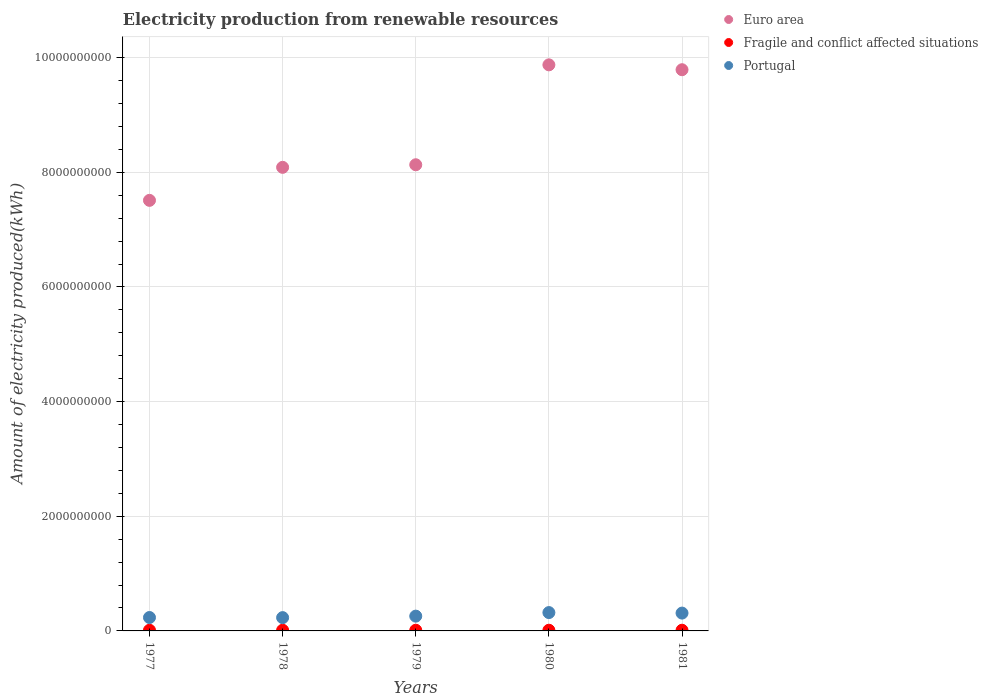What is the amount of electricity produced in Euro area in 1977?
Provide a succinct answer. 7.51e+09. Across all years, what is the minimum amount of electricity produced in Portugal?
Keep it short and to the point. 2.32e+08. In which year was the amount of electricity produced in Euro area maximum?
Ensure brevity in your answer.  1980. What is the total amount of electricity produced in Fragile and conflict affected situations in the graph?
Ensure brevity in your answer.  6.00e+07. What is the difference between the amount of electricity produced in Fragile and conflict affected situations in 1979 and the amount of electricity produced in Euro area in 1978?
Your answer should be very brief. -8.08e+09. What is the average amount of electricity produced in Euro area per year?
Keep it short and to the point. 8.68e+09. In the year 1981, what is the difference between the amount of electricity produced in Portugal and amount of electricity produced in Euro area?
Provide a short and direct response. -9.48e+09. In how many years, is the amount of electricity produced in Fragile and conflict affected situations greater than 8800000000 kWh?
Keep it short and to the point. 0. Is the amount of electricity produced in Euro area in 1977 less than that in 1981?
Your answer should be compact. Yes. Is the difference between the amount of electricity produced in Portugal in 1978 and 1979 greater than the difference between the amount of electricity produced in Euro area in 1978 and 1979?
Your answer should be very brief. Yes. What is the difference between the highest and the second highest amount of electricity produced in Portugal?
Make the answer very short. 9.00e+06. What is the difference between the highest and the lowest amount of electricity produced in Portugal?
Offer a terse response. 8.80e+07. Is the amount of electricity produced in Fragile and conflict affected situations strictly greater than the amount of electricity produced in Portugal over the years?
Offer a terse response. No. Is the amount of electricity produced in Fragile and conflict affected situations strictly less than the amount of electricity produced in Portugal over the years?
Provide a short and direct response. Yes. What is the difference between two consecutive major ticks on the Y-axis?
Give a very brief answer. 2.00e+09. Are the values on the major ticks of Y-axis written in scientific E-notation?
Your answer should be very brief. No. Does the graph contain any zero values?
Keep it short and to the point. No. Where does the legend appear in the graph?
Offer a very short reply. Top right. How many legend labels are there?
Give a very brief answer. 3. What is the title of the graph?
Make the answer very short. Electricity production from renewable resources. What is the label or title of the Y-axis?
Ensure brevity in your answer.  Amount of electricity produced(kWh). What is the Amount of electricity produced(kWh) in Euro area in 1977?
Offer a very short reply. 7.51e+09. What is the Amount of electricity produced(kWh) in Portugal in 1977?
Make the answer very short. 2.34e+08. What is the Amount of electricity produced(kWh) in Euro area in 1978?
Make the answer very short. 8.09e+09. What is the Amount of electricity produced(kWh) of Portugal in 1978?
Ensure brevity in your answer.  2.32e+08. What is the Amount of electricity produced(kWh) of Euro area in 1979?
Offer a terse response. 8.13e+09. What is the Amount of electricity produced(kWh) in Fragile and conflict affected situations in 1979?
Provide a short and direct response. 1.20e+07. What is the Amount of electricity produced(kWh) of Portugal in 1979?
Keep it short and to the point. 2.58e+08. What is the Amount of electricity produced(kWh) in Euro area in 1980?
Keep it short and to the point. 9.88e+09. What is the Amount of electricity produced(kWh) of Fragile and conflict affected situations in 1980?
Give a very brief answer. 1.20e+07. What is the Amount of electricity produced(kWh) of Portugal in 1980?
Give a very brief answer. 3.20e+08. What is the Amount of electricity produced(kWh) in Euro area in 1981?
Your answer should be compact. 9.79e+09. What is the Amount of electricity produced(kWh) of Portugal in 1981?
Offer a terse response. 3.11e+08. Across all years, what is the maximum Amount of electricity produced(kWh) of Euro area?
Ensure brevity in your answer.  9.88e+09. Across all years, what is the maximum Amount of electricity produced(kWh) of Fragile and conflict affected situations?
Make the answer very short. 1.20e+07. Across all years, what is the maximum Amount of electricity produced(kWh) of Portugal?
Provide a succinct answer. 3.20e+08. Across all years, what is the minimum Amount of electricity produced(kWh) of Euro area?
Keep it short and to the point. 7.51e+09. Across all years, what is the minimum Amount of electricity produced(kWh) of Fragile and conflict affected situations?
Make the answer very short. 1.20e+07. Across all years, what is the minimum Amount of electricity produced(kWh) of Portugal?
Provide a short and direct response. 2.32e+08. What is the total Amount of electricity produced(kWh) in Euro area in the graph?
Offer a terse response. 4.34e+1. What is the total Amount of electricity produced(kWh) in Fragile and conflict affected situations in the graph?
Make the answer very short. 6.00e+07. What is the total Amount of electricity produced(kWh) of Portugal in the graph?
Your answer should be very brief. 1.36e+09. What is the difference between the Amount of electricity produced(kWh) in Euro area in 1977 and that in 1978?
Give a very brief answer. -5.76e+08. What is the difference between the Amount of electricity produced(kWh) in Euro area in 1977 and that in 1979?
Offer a terse response. -6.21e+08. What is the difference between the Amount of electricity produced(kWh) of Fragile and conflict affected situations in 1977 and that in 1979?
Make the answer very short. 0. What is the difference between the Amount of electricity produced(kWh) of Portugal in 1977 and that in 1979?
Your answer should be very brief. -2.40e+07. What is the difference between the Amount of electricity produced(kWh) in Euro area in 1977 and that in 1980?
Give a very brief answer. -2.36e+09. What is the difference between the Amount of electricity produced(kWh) in Fragile and conflict affected situations in 1977 and that in 1980?
Provide a succinct answer. 0. What is the difference between the Amount of electricity produced(kWh) in Portugal in 1977 and that in 1980?
Keep it short and to the point. -8.60e+07. What is the difference between the Amount of electricity produced(kWh) in Euro area in 1977 and that in 1981?
Offer a very short reply. -2.28e+09. What is the difference between the Amount of electricity produced(kWh) of Fragile and conflict affected situations in 1977 and that in 1981?
Give a very brief answer. 0. What is the difference between the Amount of electricity produced(kWh) in Portugal in 1977 and that in 1981?
Give a very brief answer. -7.70e+07. What is the difference between the Amount of electricity produced(kWh) in Euro area in 1978 and that in 1979?
Offer a very short reply. -4.50e+07. What is the difference between the Amount of electricity produced(kWh) in Fragile and conflict affected situations in 1978 and that in 1979?
Provide a short and direct response. 0. What is the difference between the Amount of electricity produced(kWh) in Portugal in 1978 and that in 1979?
Your answer should be very brief. -2.60e+07. What is the difference between the Amount of electricity produced(kWh) in Euro area in 1978 and that in 1980?
Make the answer very short. -1.79e+09. What is the difference between the Amount of electricity produced(kWh) of Fragile and conflict affected situations in 1978 and that in 1980?
Your answer should be compact. 0. What is the difference between the Amount of electricity produced(kWh) in Portugal in 1978 and that in 1980?
Offer a very short reply. -8.80e+07. What is the difference between the Amount of electricity produced(kWh) in Euro area in 1978 and that in 1981?
Give a very brief answer. -1.70e+09. What is the difference between the Amount of electricity produced(kWh) of Portugal in 1978 and that in 1981?
Your answer should be compact. -7.90e+07. What is the difference between the Amount of electricity produced(kWh) of Euro area in 1979 and that in 1980?
Make the answer very short. -1.74e+09. What is the difference between the Amount of electricity produced(kWh) of Fragile and conflict affected situations in 1979 and that in 1980?
Give a very brief answer. 0. What is the difference between the Amount of electricity produced(kWh) in Portugal in 1979 and that in 1980?
Your answer should be very brief. -6.20e+07. What is the difference between the Amount of electricity produced(kWh) in Euro area in 1979 and that in 1981?
Offer a very short reply. -1.66e+09. What is the difference between the Amount of electricity produced(kWh) of Fragile and conflict affected situations in 1979 and that in 1981?
Your response must be concise. 0. What is the difference between the Amount of electricity produced(kWh) of Portugal in 1979 and that in 1981?
Give a very brief answer. -5.30e+07. What is the difference between the Amount of electricity produced(kWh) of Euro area in 1980 and that in 1981?
Provide a short and direct response. 8.50e+07. What is the difference between the Amount of electricity produced(kWh) of Portugal in 1980 and that in 1981?
Your answer should be very brief. 9.00e+06. What is the difference between the Amount of electricity produced(kWh) in Euro area in 1977 and the Amount of electricity produced(kWh) in Fragile and conflict affected situations in 1978?
Offer a terse response. 7.50e+09. What is the difference between the Amount of electricity produced(kWh) in Euro area in 1977 and the Amount of electricity produced(kWh) in Portugal in 1978?
Your answer should be very brief. 7.28e+09. What is the difference between the Amount of electricity produced(kWh) of Fragile and conflict affected situations in 1977 and the Amount of electricity produced(kWh) of Portugal in 1978?
Give a very brief answer. -2.20e+08. What is the difference between the Amount of electricity produced(kWh) in Euro area in 1977 and the Amount of electricity produced(kWh) in Fragile and conflict affected situations in 1979?
Offer a terse response. 7.50e+09. What is the difference between the Amount of electricity produced(kWh) in Euro area in 1977 and the Amount of electricity produced(kWh) in Portugal in 1979?
Ensure brevity in your answer.  7.25e+09. What is the difference between the Amount of electricity produced(kWh) in Fragile and conflict affected situations in 1977 and the Amount of electricity produced(kWh) in Portugal in 1979?
Keep it short and to the point. -2.46e+08. What is the difference between the Amount of electricity produced(kWh) in Euro area in 1977 and the Amount of electricity produced(kWh) in Fragile and conflict affected situations in 1980?
Provide a short and direct response. 7.50e+09. What is the difference between the Amount of electricity produced(kWh) of Euro area in 1977 and the Amount of electricity produced(kWh) of Portugal in 1980?
Your answer should be very brief. 7.19e+09. What is the difference between the Amount of electricity produced(kWh) of Fragile and conflict affected situations in 1977 and the Amount of electricity produced(kWh) of Portugal in 1980?
Offer a terse response. -3.08e+08. What is the difference between the Amount of electricity produced(kWh) in Euro area in 1977 and the Amount of electricity produced(kWh) in Fragile and conflict affected situations in 1981?
Provide a succinct answer. 7.50e+09. What is the difference between the Amount of electricity produced(kWh) of Euro area in 1977 and the Amount of electricity produced(kWh) of Portugal in 1981?
Offer a terse response. 7.20e+09. What is the difference between the Amount of electricity produced(kWh) in Fragile and conflict affected situations in 1977 and the Amount of electricity produced(kWh) in Portugal in 1981?
Your response must be concise. -2.99e+08. What is the difference between the Amount of electricity produced(kWh) in Euro area in 1978 and the Amount of electricity produced(kWh) in Fragile and conflict affected situations in 1979?
Offer a terse response. 8.08e+09. What is the difference between the Amount of electricity produced(kWh) of Euro area in 1978 and the Amount of electricity produced(kWh) of Portugal in 1979?
Make the answer very short. 7.83e+09. What is the difference between the Amount of electricity produced(kWh) in Fragile and conflict affected situations in 1978 and the Amount of electricity produced(kWh) in Portugal in 1979?
Provide a succinct answer. -2.46e+08. What is the difference between the Amount of electricity produced(kWh) in Euro area in 1978 and the Amount of electricity produced(kWh) in Fragile and conflict affected situations in 1980?
Offer a very short reply. 8.08e+09. What is the difference between the Amount of electricity produced(kWh) in Euro area in 1978 and the Amount of electricity produced(kWh) in Portugal in 1980?
Offer a very short reply. 7.77e+09. What is the difference between the Amount of electricity produced(kWh) of Fragile and conflict affected situations in 1978 and the Amount of electricity produced(kWh) of Portugal in 1980?
Make the answer very short. -3.08e+08. What is the difference between the Amount of electricity produced(kWh) of Euro area in 1978 and the Amount of electricity produced(kWh) of Fragile and conflict affected situations in 1981?
Keep it short and to the point. 8.08e+09. What is the difference between the Amount of electricity produced(kWh) in Euro area in 1978 and the Amount of electricity produced(kWh) in Portugal in 1981?
Offer a terse response. 7.78e+09. What is the difference between the Amount of electricity produced(kWh) in Fragile and conflict affected situations in 1978 and the Amount of electricity produced(kWh) in Portugal in 1981?
Provide a short and direct response. -2.99e+08. What is the difference between the Amount of electricity produced(kWh) of Euro area in 1979 and the Amount of electricity produced(kWh) of Fragile and conflict affected situations in 1980?
Your answer should be very brief. 8.12e+09. What is the difference between the Amount of electricity produced(kWh) of Euro area in 1979 and the Amount of electricity produced(kWh) of Portugal in 1980?
Make the answer very short. 7.81e+09. What is the difference between the Amount of electricity produced(kWh) in Fragile and conflict affected situations in 1979 and the Amount of electricity produced(kWh) in Portugal in 1980?
Provide a short and direct response. -3.08e+08. What is the difference between the Amount of electricity produced(kWh) of Euro area in 1979 and the Amount of electricity produced(kWh) of Fragile and conflict affected situations in 1981?
Give a very brief answer. 8.12e+09. What is the difference between the Amount of electricity produced(kWh) of Euro area in 1979 and the Amount of electricity produced(kWh) of Portugal in 1981?
Provide a succinct answer. 7.82e+09. What is the difference between the Amount of electricity produced(kWh) of Fragile and conflict affected situations in 1979 and the Amount of electricity produced(kWh) of Portugal in 1981?
Your response must be concise. -2.99e+08. What is the difference between the Amount of electricity produced(kWh) of Euro area in 1980 and the Amount of electricity produced(kWh) of Fragile and conflict affected situations in 1981?
Your answer should be very brief. 9.86e+09. What is the difference between the Amount of electricity produced(kWh) of Euro area in 1980 and the Amount of electricity produced(kWh) of Portugal in 1981?
Ensure brevity in your answer.  9.56e+09. What is the difference between the Amount of electricity produced(kWh) of Fragile and conflict affected situations in 1980 and the Amount of electricity produced(kWh) of Portugal in 1981?
Your response must be concise. -2.99e+08. What is the average Amount of electricity produced(kWh) in Euro area per year?
Give a very brief answer. 8.68e+09. What is the average Amount of electricity produced(kWh) of Portugal per year?
Your response must be concise. 2.71e+08. In the year 1977, what is the difference between the Amount of electricity produced(kWh) of Euro area and Amount of electricity produced(kWh) of Fragile and conflict affected situations?
Keep it short and to the point. 7.50e+09. In the year 1977, what is the difference between the Amount of electricity produced(kWh) in Euro area and Amount of electricity produced(kWh) in Portugal?
Give a very brief answer. 7.28e+09. In the year 1977, what is the difference between the Amount of electricity produced(kWh) of Fragile and conflict affected situations and Amount of electricity produced(kWh) of Portugal?
Your answer should be compact. -2.22e+08. In the year 1978, what is the difference between the Amount of electricity produced(kWh) in Euro area and Amount of electricity produced(kWh) in Fragile and conflict affected situations?
Ensure brevity in your answer.  8.08e+09. In the year 1978, what is the difference between the Amount of electricity produced(kWh) of Euro area and Amount of electricity produced(kWh) of Portugal?
Provide a short and direct response. 7.86e+09. In the year 1978, what is the difference between the Amount of electricity produced(kWh) of Fragile and conflict affected situations and Amount of electricity produced(kWh) of Portugal?
Your answer should be very brief. -2.20e+08. In the year 1979, what is the difference between the Amount of electricity produced(kWh) of Euro area and Amount of electricity produced(kWh) of Fragile and conflict affected situations?
Offer a terse response. 8.12e+09. In the year 1979, what is the difference between the Amount of electricity produced(kWh) in Euro area and Amount of electricity produced(kWh) in Portugal?
Give a very brief answer. 7.87e+09. In the year 1979, what is the difference between the Amount of electricity produced(kWh) in Fragile and conflict affected situations and Amount of electricity produced(kWh) in Portugal?
Give a very brief answer. -2.46e+08. In the year 1980, what is the difference between the Amount of electricity produced(kWh) of Euro area and Amount of electricity produced(kWh) of Fragile and conflict affected situations?
Your answer should be very brief. 9.86e+09. In the year 1980, what is the difference between the Amount of electricity produced(kWh) of Euro area and Amount of electricity produced(kWh) of Portugal?
Provide a short and direct response. 9.56e+09. In the year 1980, what is the difference between the Amount of electricity produced(kWh) of Fragile and conflict affected situations and Amount of electricity produced(kWh) of Portugal?
Offer a terse response. -3.08e+08. In the year 1981, what is the difference between the Amount of electricity produced(kWh) in Euro area and Amount of electricity produced(kWh) in Fragile and conflict affected situations?
Your answer should be compact. 9.78e+09. In the year 1981, what is the difference between the Amount of electricity produced(kWh) in Euro area and Amount of electricity produced(kWh) in Portugal?
Make the answer very short. 9.48e+09. In the year 1981, what is the difference between the Amount of electricity produced(kWh) in Fragile and conflict affected situations and Amount of electricity produced(kWh) in Portugal?
Provide a succinct answer. -2.99e+08. What is the ratio of the Amount of electricity produced(kWh) of Euro area in 1977 to that in 1978?
Offer a terse response. 0.93. What is the ratio of the Amount of electricity produced(kWh) of Portugal in 1977 to that in 1978?
Your response must be concise. 1.01. What is the ratio of the Amount of electricity produced(kWh) of Euro area in 1977 to that in 1979?
Provide a short and direct response. 0.92. What is the ratio of the Amount of electricity produced(kWh) in Fragile and conflict affected situations in 1977 to that in 1979?
Offer a terse response. 1. What is the ratio of the Amount of electricity produced(kWh) in Portugal in 1977 to that in 1979?
Offer a very short reply. 0.91. What is the ratio of the Amount of electricity produced(kWh) in Euro area in 1977 to that in 1980?
Your response must be concise. 0.76. What is the ratio of the Amount of electricity produced(kWh) of Fragile and conflict affected situations in 1977 to that in 1980?
Ensure brevity in your answer.  1. What is the ratio of the Amount of electricity produced(kWh) of Portugal in 1977 to that in 1980?
Keep it short and to the point. 0.73. What is the ratio of the Amount of electricity produced(kWh) of Euro area in 1977 to that in 1981?
Your answer should be compact. 0.77. What is the ratio of the Amount of electricity produced(kWh) of Portugal in 1977 to that in 1981?
Provide a short and direct response. 0.75. What is the ratio of the Amount of electricity produced(kWh) of Euro area in 1978 to that in 1979?
Your answer should be compact. 0.99. What is the ratio of the Amount of electricity produced(kWh) of Portugal in 1978 to that in 1979?
Offer a very short reply. 0.9. What is the ratio of the Amount of electricity produced(kWh) of Euro area in 1978 to that in 1980?
Your response must be concise. 0.82. What is the ratio of the Amount of electricity produced(kWh) in Fragile and conflict affected situations in 1978 to that in 1980?
Your answer should be very brief. 1. What is the ratio of the Amount of electricity produced(kWh) of Portugal in 1978 to that in 1980?
Your answer should be compact. 0.72. What is the ratio of the Amount of electricity produced(kWh) in Euro area in 1978 to that in 1981?
Ensure brevity in your answer.  0.83. What is the ratio of the Amount of electricity produced(kWh) of Portugal in 1978 to that in 1981?
Offer a very short reply. 0.75. What is the ratio of the Amount of electricity produced(kWh) in Euro area in 1979 to that in 1980?
Your answer should be very brief. 0.82. What is the ratio of the Amount of electricity produced(kWh) in Portugal in 1979 to that in 1980?
Your answer should be compact. 0.81. What is the ratio of the Amount of electricity produced(kWh) of Euro area in 1979 to that in 1981?
Ensure brevity in your answer.  0.83. What is the ratio of the Amount of electricity produced(kWh) of Fragile and conflict affected situations in 1979 to that in 1981?
Your answer should be very brief. 1. What is the ratio of the Amount of electricity produced(kWh) of Portugal in 1979 to that in 1981?
Your response must be concise. 0.83. What is the ratio of the Amount of electricity produced(kWh) in Euro area in 1980 to that in 1981?
Give a very brief answer. 1.01. What is the ratio of the Amount of electricity produced(kWh) in Portugal in 1980 to that in 1981?
Give a very brief answer. 1.03. What is the difference between the highest and the second highest Amount of electricity produced(kWh) in Euro area?
Ensure brevity in your answer.  8.50e+07. What is the difference between the highest and the second highest Amount of electricity produced(kWh) of Fragile and conflict affected situations?
Make the answer very short. 0. What is the difference between the highest and the second highest Amount of electricity produced(kWh) in Portugal?
Ensure brevity in your answer.  9.00e+06. What is the difference between the highest and the lowest Amount of electricity produced(kWh) of Euro area?
Keep it short and to the point. 2.36e+09. What is the difference between the highest and the lowest Amount of electricity produced(kWh) in Fragile and conflict affected situations?
Provide a succinct answer. 0. What is the difference between the highest and the lowest Amount of electricity produced(kWh) of Portugal?
Your answer should be compact. 8.80e+07. 